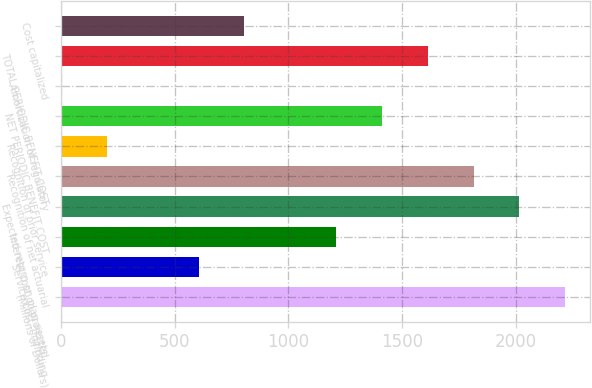Convert chart. <chart><loc_0><loc_0><loc_500><loc_500><bar_chart><fcel>(Millions of Dollars)<fcel>Service cost - including<fcel>Interest cost on projected<fcel>Expected return on plan assets<fcel>Recognition of net actuarial<fcel>Recognition of prior service<fcel>NET PERIODIC BENEFIT COST<fcel>Amortization of regulatory<fcel>TOTAL PERIODIC BENEFIT COST<fcel>Cost capitalized<nl><fcel>2216.4<fcel>605.2<fcel>1209.4<fcel>2015<fcel>1813.6<fcel>202.4<fcel>1410.8<fcel>1<fcel>1612.2<fcel>806.6<nl></chart> 